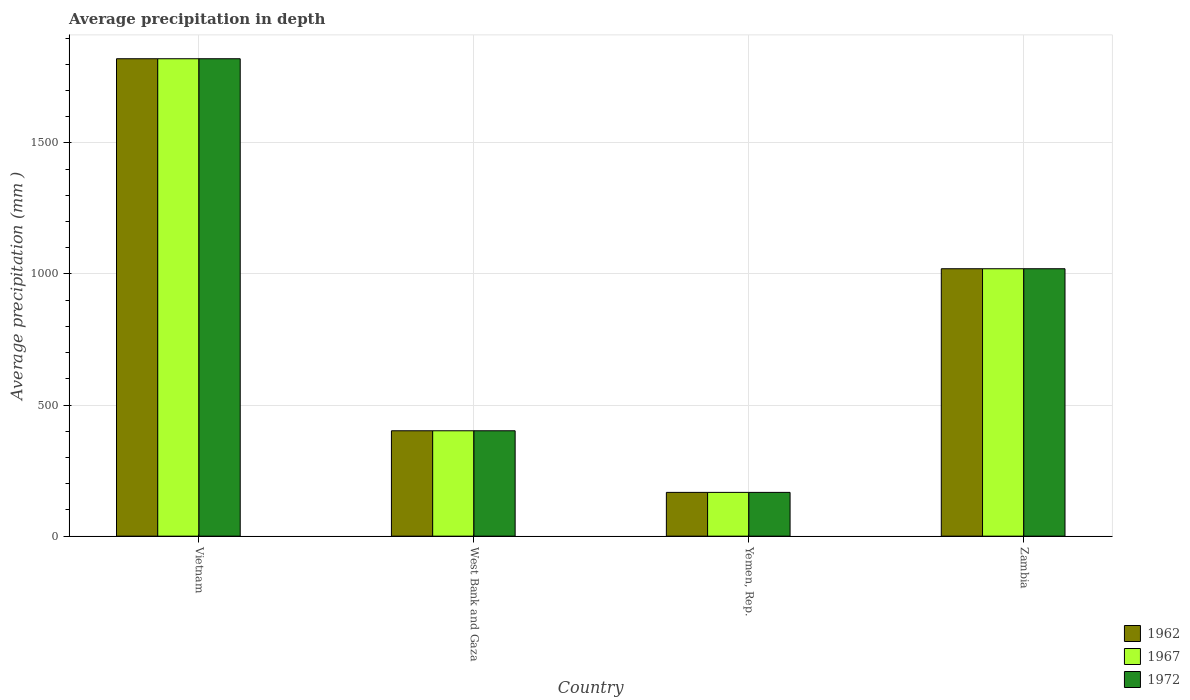How many groups of bars are there?
Offer a very short reply. 4. Are the number of bars per tick equal to the number of legend labels?
Provide a short and direct response. Yes. How many bars are there on the 2nd tick from the right?
Provide a short and direct response. 3. What is the label of the 4th group of bars from the left?
Offer a terse response. Zambia. What is the average precipitation in 1962 in Yemen, Rep.?
Provide a short and direct response. 167. Across all countries, what is the maximum average precipitation in 1967?
Make the answer very short. 1821. Across all countries, what is the minimum average precipitation in 1962?
Your response must be concise. 167. In which country was the average precipitation in 1962 maximum?
Make the answer very short. Vietnam. In which country was the average precipitation in 1972 minimum?
Ensure brevity in your answer.  Yemen, Rep. What is the total average precipitation in 1972 in the graph?
Your answer should be compact. 3410. What is the difference between the average precipitation in 1962 in Vietnam and that in West Bank and Gaza?
Offer a very short reply. 1419. What is the difference between the average precipitation in 1972 in West Bank and Gaza and the average precipitation in 1967 in Yemen, Rep.?
Make the answer very short. 235. What is the average average precipitation in 1972 per country?
Offer a very short reply. 852.5. What is the ratio of the average precipitation in 1967 in Vietnam to that in Zambia?
Your answer should be very brief. 1.79. What is the difference between the highest and the second highest average precipitation in 1972?
Offer a very short reply. -618. What is the difference between the highest and the lowest average precipitation in 1972?
Offer a terse response. 1654. In how many countries, is the average precipitation in 1962 greater than the average average precipitation in 1962 taken over all countries?
Give a very brief answer. 2. What does the 2nd bar from the left in Yemen, Rep. represents?
Your response must be concise. 1967. Are all the bars in the graph horizontal?
Keep it short and to the point. No. How many legend labels are there?
Provide a succinct answer. 3. How are the legend labels stacked?
Offer a terse response. Vertical. What is the title of the graph?
Provide a short and direct response. Average precipitation in depth. Does "2005" appear as one of the legend labels in the graph?
Provide a short and direct response. No. What is the label or title of the X-axis?
Keep it short and to the point. Country. What is the label or title of the Y-axis?
Provide a succinct answer. Average precipitation (mm ). What is the Average precipitation (mm ) in 1962 in Vietnam?
Provide a short and direct response. 1821. What is the Average precipitation (mm ) of 1967 in Vietnam?
Ensure brevity in your answer.  1821. What is the Average precipitation (mm ) in 1972 in Vietnam?
Your response must be concise. 1821. What is the Average precipitation (mm ) in 1962 in West Bank and Gaza?
Give a very brief answer. 402. What is the Average precipitation (mm ) of 1967 in West Bank and Gaza?
Your answer should be very brief. 402. What is the Average precipitation (mm ) of 1972 in West Bank and Gaza?
Your answer should be very brief. 402. What is the Average precipitation (mm ) in 1962 in Yemen, Rep.?
Provide a succinct answer. 167. What is the Average precipitation (mm ) in 1967 in Yemen, Rep.?
Offer a terse response. 167. What is the Average precipitation (mm ) in 1972 in Yemen, Rep.?
Offer a terse response. 167. What is the Average precipitation (mm ) of 1962 in Zambia?
Provide a short and direct response. 1020. What is the Average precipitation (mm ) in 1967 in Zambia?
Offer a very short reply. 1020. What is the Average precipitation (mm ) of 1972 in Zambia?
Ensure brevity in your answer.  1020. Across all countries, what is the maximum Average precipitation (mm ) in 1962?
Your answer should be very brief. 1821. Across all countries, what is the maximum Average precipitation (mm ) of 1967?
Your answer should be compact. 1821. Across all countries, what is the maximum Average precipitation (mm ) of 1972?
Make the answer very short. 1821. Across all countries, what is the minimum Average precipitation (mm ) in 1962?
Offer a terse response. 167. Across all countries, what is the minimum Average precipitation (mm ) in 1967?
Provide a succinct answer. 167. Across all countries, what is the minimum Average precipitation (mm ) in 1972?
Provide a short and direct response. 167. What is the total Average precipitation (mm ) in 1962 in the graph?
Make the answer very short. 3410. What is the total Average precipitation (mm ) of 1967 in the graph?
Keep it short and to the point. 3410. What is the total Average precipitation (mm ) in 1972 in the graph?
Provide a short and direct response. 3410. What is the difference between the Average precipitation (mm ) of 1962 in Vietnam and that in West Bank and Gaza?
Your response must be concise. 1419. What is the difference between the Average precipitation (mm ) of 1967 in Vietnam and that in West Bank and Gaza?
Give a very brief answer. 1419. What is the difference between the Average precipitation (mm ) in 1972 in Vietnam and that in West Bank and Gaza?
Offer a very short reply. 1419. What is the difference between the Average precipitation (mm ) of 1962 in Vietnam and that in Yemen, Rep.?
Your response must be concise. 1654. What is the difference between the Average precipitation (mm ) in 1967 in Vietnam and that in Yemen, Rep.?
Your answer should be compact. 1654. What is the difference between the Average precipitation (mm ) in 1972 in Vietnam and that in Yemen, Rep.?
Your answer should be very brief. 1654. What is the difference between the Average precipitation (mm ) in 1962 in Vietnam and that in Zambia?
Your answer should be compact. 801. What is the difference between the Average precipitation (mm ) in 1967 in Vietnam and that in Zambia?
Offer a very short reply. 801. What is the difference between the Average precipitation (mm ) in 1972 in Vietnam and that in Zambia?
Offer a terse response. 801. What is the difference between the Average precipitation (mm ) in 1962 in West Bank and Gaza and that in Yemen, Rep.?
Make the answer very short. 235. What is the difference between the Average precipitation (mm ) in 1967 in West Bank and Gaza and that in Yemen, Rep.?
Provide a short and direct response. 235. What is the difference between the Average precipitation (mm ) of 1972 in West Bank and Gaza and that in Yemen, Rep.?
Keep it short and to the point. 235. What is the difference between the Average precipitation (mm ) in 1962 in West Bank and Gaza and that in Zambia?
Make the answer very short. -618. What is the difference between the Average precipitation (mm ) in 1967 in West Bank and Gaza and that in Zambia?
Your response must be concise. -618. What is the difference between the Average precipitation (mm ) in 1972 in West Bank and Gaza and that in Zambia?
Offer a very short reply. -618. What is the difference between the Average precipitation (mm ) of 1962 in Yemen, Rep. and that in Zambia?
Your response must be concise. -853. What is the difference between the Average precipitation (mm ) of 1967 in Yemen, Rep. and that in Zambia?
Make the answer very short. -853. What is the difference between the Average precipitation (mm ) of 1972 in Yemen, Rep. and that in Zambia?
Give a very brief answer. -853. What is the difference between the Average precipitation (mm ) in 1962 in Vietnam and the Average precipitation (mm ) in 1967 in West Bank and Gaza?
Provide a short and direct response. 1419. What is the difference between the Average precipitation (mm ) of 1962 in Vietnam and the Average precipitation (mm ) of 1972 in West Bank and Gaza?
Ensure brevity in your answer.  1419. What is the difference between the Average precipitation (mm ) of 1967 in Vietnam and the Average precipitation (mm ) of 1972 in West Bank and Gaza?
Provide a succinct answer. 1419. What is the difference between the Average precipitation (mm ) of 1962 in Vietnam and the Average precipitation (mm ) of 1967 in Yemen, Rep.?
Make the answer very short. 1654. What is the difference between the Average precipitation (mm ) of 1962 in Vietnam and the Average precipitation (mm ) of 1972 in Yemen, Rep.?
Offer a terse response. 1654. What is the difference between the Average precipitation (mm ) of 1967 in Vietnam and the Average precipitation (mm ) of 1972 in Yemen, Rep.?
Your answer should be very brief. 1654. What is the difference between the Average precipitation (mm ) in 1962 in Vietnam and the Average precipitation (mm ) in 1967 in Zambia?
Your response must be concise. 801. What is the difference between the Average precipitation (mm ) in 1962 in Vietnam and the Average precipitation (mm ) in 1972 in Zambia?
Your answer should be very brief. 801. What is the difference between the Average precipitation (mm ) in 1967 in Vietnam and the Average precipitation (mm ) in 1972 in Zambia?
Provide a short and direct response. 801. What is the difference between the Average precipitation (mm ) in 1962 in West Bank and Gaza and the Average precipitation (mm ) in 1967 in Yemen, Rep.?
Provide a succinct answer. 235. What is the difference between the Average precipitation (mm ) in 1962 in West Bank and Gaza and the Average precipitation (mm ) in 1972 in Yemen, Rep.?
Your response must be concise. 235. What is the difference between the Average precipitation (mm ) in 1967 in West Bank and Gaza and the Average precipitation (mm ) in 1972 in Yemen, Rep.?
Offer a very short reply. 235. What is the difference between the Average precipitation (mm ) in 1962 in West Bank and Gaza and the Average precipitation (mm ) in 1967 in Zambia?
Your response must be concise. -618. What is the difference between the Average precipitation (mm ) in 1962 in West Bank and Gaza and the Average precipitation (mm ) in 1972 in Zambia?
Keep it short and to the point. -618. What is the difference between the Average precipitation (mm ) of 1967 in West Bank and Gaza and the Average precipitation (mm ) of 1972 in Zambia?
Your response must be concise. -618. What is the difference between the Average precipitation (mm ) of 1962 in Yemen, Rep. and the Average precipitation (mm ) of 1967 in Zambia?
Your answer should be compact. -853. What is the difference between the Average precipitation (mm ) in 1962 in Yemen, Rep. and the Average precipitation (mm ) in 1972 in Zambia?
Your answer should be compact. -853. What is the difference between the Average precipitation (mm ) in 1967 in Yemen, Rep. and the Average precipitation (mm ) in 1972 in Zambia?
Offer a very short reply. -853. What is the average Average precipitation (mm ) of 1962 per country?
Provide a succinct answer. 852.5. What is the average Average precipitation (mm ) of 1967 per country?
Provide a short and direct response. 852.5. What is the average Average precipitation (mm ) in 1972 per country?
Your response must be concise. 852.5. What is the difference between the Average precipitation (mm ) of 1967 and Average precipitation (mm ) of 1972 in West Bank and Gaza?
Your answer should be compact. 0. What is the difference between the Average precipitation (mm ) of 1962 and Average precipitation (mm ) of 1967 in Yemen, Rep.?
Keep it short and to the point. 0. What is the difference between the Average precipitation (mm ) in 1967 and Average precipitation (mm ) in 1972 in Yemen, Rep.?
Make the answer very short. 0. What is the difference between the Average precipitation (mm ) in 1962 and Average precipitation (mm ) in 1972 in Zambia?
Provide a succinct answer. 0. What is the ratio of the Average precipitation (mm ) in 1962 in Vietnam to that in West Bank and Gaza?
Keep it short and to the point. 4.53. What is the ratio of the Average precipitation (mm ) in 1967 in Vietnam to that in West Bank and Gaza?
Offer a very short reply. 4.53. What is the ratio of the Average precipitation (mm ) of 1972 in Vietnam to that in West Bank and Gaza?
Make the answer very short. 4.53. What is the ratio of the Average precipitation (mm ) of 1962 in Vietnam to that in Yemen, Rep.?
Ensure brevity in your answer.  10.9. What is the ratio of the Average precipitation (mm ) of 1967 in Vietnam to that in Yemen, Rep.?
Your answer should be very brief. 10.9. What is the ratio of the Average precipitation (mm ) of 1972 in Vietnam to that in Yemen, Rep.?
Keep it short and to the point. 10.9. What is the ratio of the Average precipitation (mm ) of 1962 in Vietnam to that in Zambia?
Your answer should be compact. 1.79. What is the ratio of the Average precipitation (mm ) of 1967 in Vietnam to that in Zambia?
Give a very brief answer. 1.79. What is the ratio of the Average precipitation (mm ) in 1972 in Vietnam to that in Zambia?
Your answer should be compact. 1.79. What is the ratio of the Average precipitation (mm ) in 1962 in West Bank and Gaza to that in Yemen, Rep.?
Provide a succinct answer. 2.41. What is the ratio of the Average precipitation (mm ) of 1967 in West Bank and Gaza to that in Yemen, Rep.?
Offer a terse response. 2.41. What is the ratio of the Average precipitation (mm ) in 1972 in West Bank and Gaza to that in Yemen, Rep.?
Your answer should be compact. 2.41. What is the ratio of the Average precipitation (mm ) in 1962 in West Bank and Gaza to that in Zambia?
Make the answer very short. 0.39. What is the ratio of the Average precipitation (mm ) in 1967 in West Bank and Gaza to that in Zambia?
Your answer should be very brief. 0.39. What is the ratio of the Average precipitation (mm ) in 1972 in West Bank and Gaza to that in Zambia?
Provide a succinct answer. 0.39. What is the ratio of the Average precipitation (mm ) in 1962 in Yemen, Rep. to that in Zambia?
Ensure brevity in your answer.  0.16. What is the ratio of the Average precipitation (mm ) in 1967 in Yemen, Rep. to that in Zambia?
Keep it short and to the point. 0.16. What is the ratio of the Average precipitation (mm ) in 1972 in Yemen, Rep. to that in Zambia?
Keep it short and to the point. 0.16. What is the difference between the highest and the second highest Average precipitation (mm ) in 1962?
Give a very brief answer. 801. What is the difference between the highest and the second highest Average precipitation (mm ) in 1967?
Make the answer very short. 801. What is the difference between the highest and the second highest Average precipitation (mm ) of 1972?
Keep it short and to the point. 801. What is the difference between the highest and the lowest Average precipitation (mm ) of 1962?
Offer a very short reply. 1654. What is the difference between the highest and the lowest Average precipitation (mm ) in 1967?
Offer a very short reply. 1654. What is the difference between the highest and the lowest Average precipitation (mm ) in 1972?
Keep it short and to the point. 1654. 